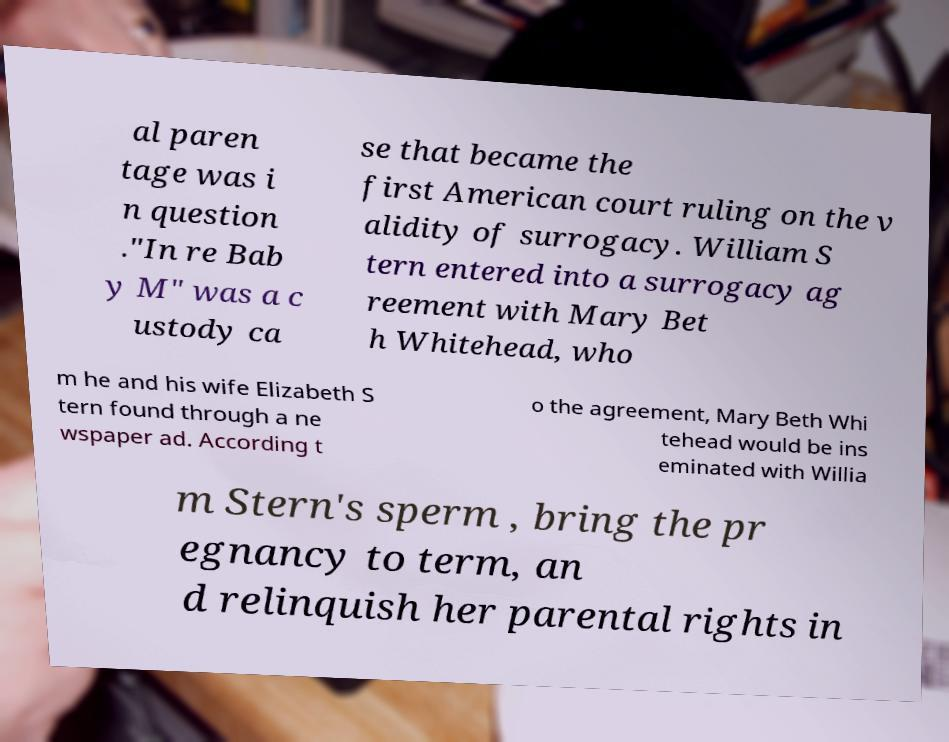Can you accurately transcribe the text from the provided image for me? al paren tage was i n question ."In re Bab y M" was a c ustody ca se that became the first American court ruling on the v alidity of surrogacy. William S tern entered into a surrogacy ag reement with Mary Bet h Whitehead, who m he and his wife Elizabeth S tern found through a ne wspaper ad. According t o the agreement, Mary Beth Whi tehead would be ins eminated with Willia m Stern's sperm , bring the pr egnancy to term, an d relinquish her parental rights in 